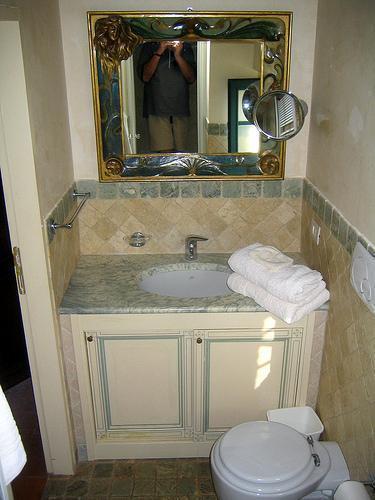How many toilets are shown?
Give a very brief answer. 1. 